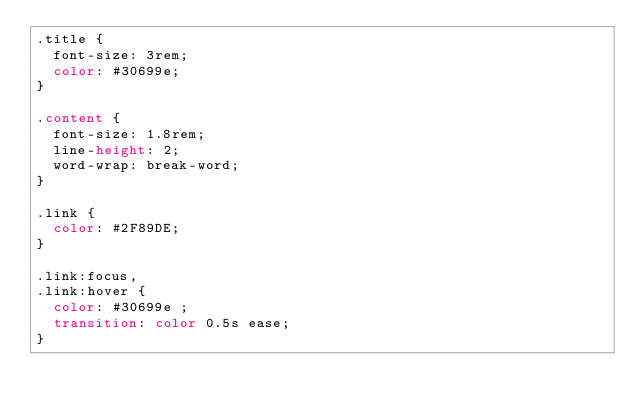Convert code to text. <code><loc_0><loc_0><loc_500><loc_500><_CSS_>.title {
  font-size: 3rem;
  color: #30699e;
}

.content {
  font-size: 1.8rem;
  line-height: 2;
  word-wrap: break-word;
}

.link {
  color: #2F89DE;
}

.link:focus,
.link:hover {
  color: #30699e ;
  transition: color 0.5s ease;
}</code> 